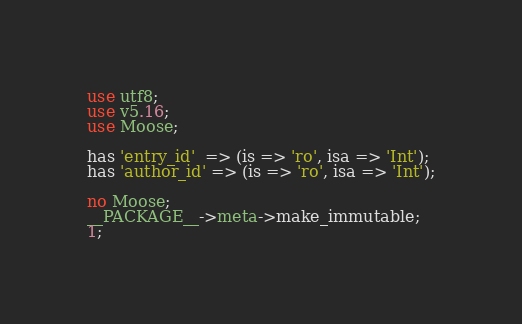Convert code to text. <code><loc_0><loc_0><loc_500><loc_500><_Perl_>
use utf8;
use v5.16;
use Moose;

has 'entry_id'  => (is => 'ro', isa => 'Int');
has 'author_id' => (is => 'ro', isa => 'Int');

no Moose;
__PACKAGE__->meta->make_immutable;
1;
</code> 